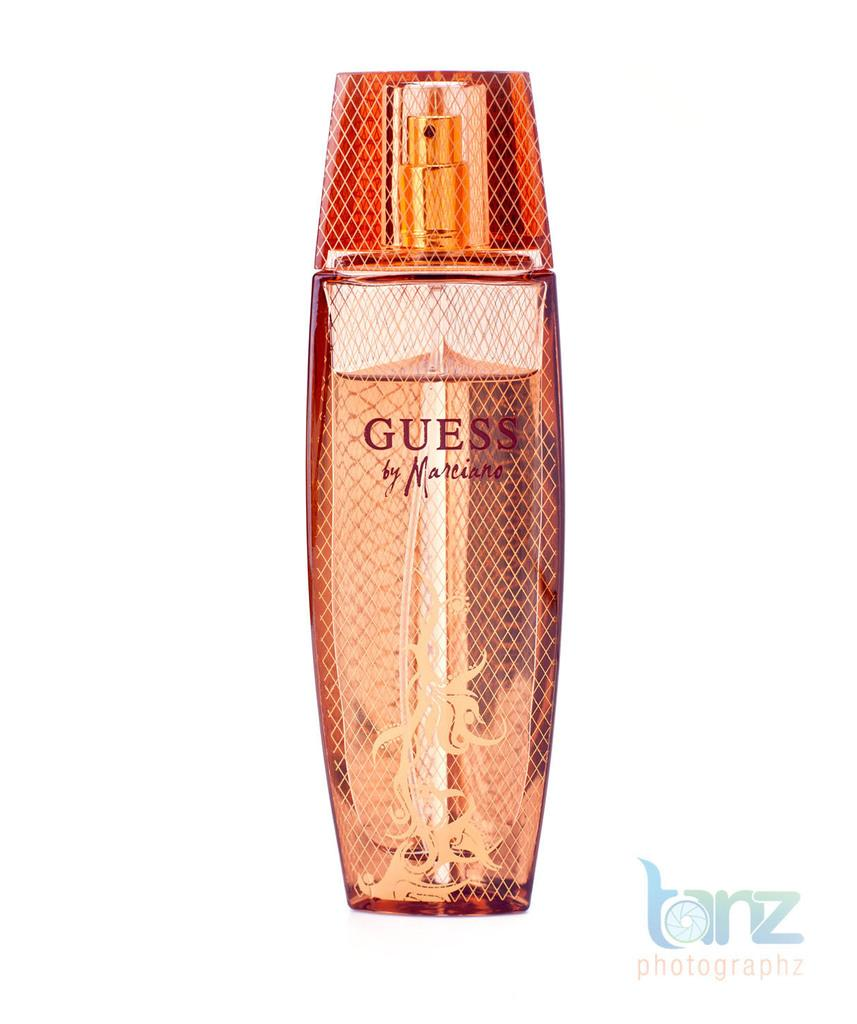Provide a one-sentence caption for the provided image. GUESS by Marciano comes in a very attractive bottle. 